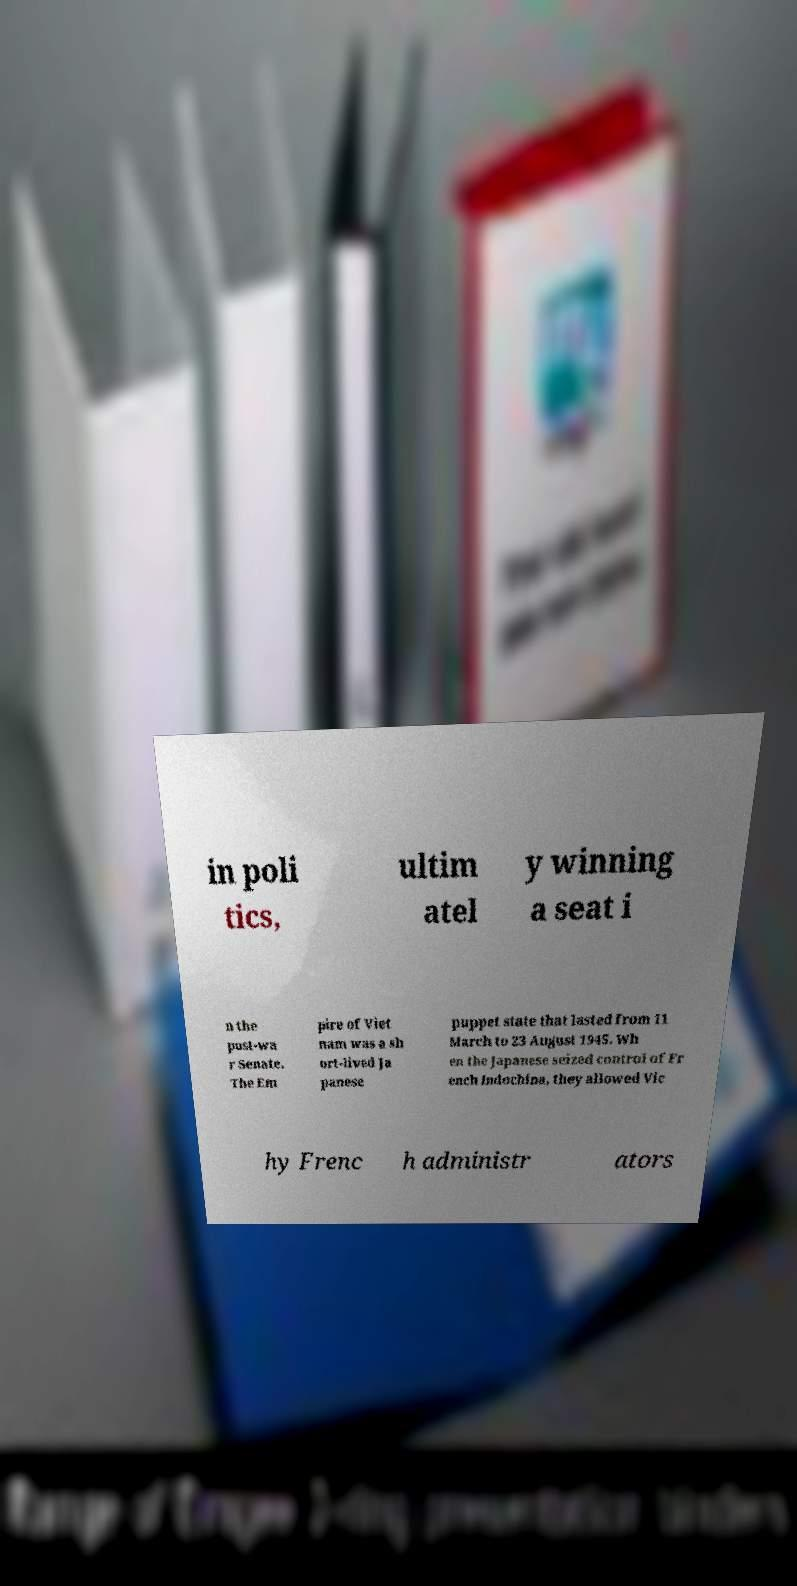Please identify and transcribe the text found in this image. in poli tics, ultim atel y winning a seat i n the post-wa r Senate. The Em pire of Viet nam was a sh ort-lived Ja panese puppet state that lasted from 11 March to 23 August 1945. Wh en the Japanese seized control of Fr ench Indochina, they allowed Vic hy Frenc h administr ators 